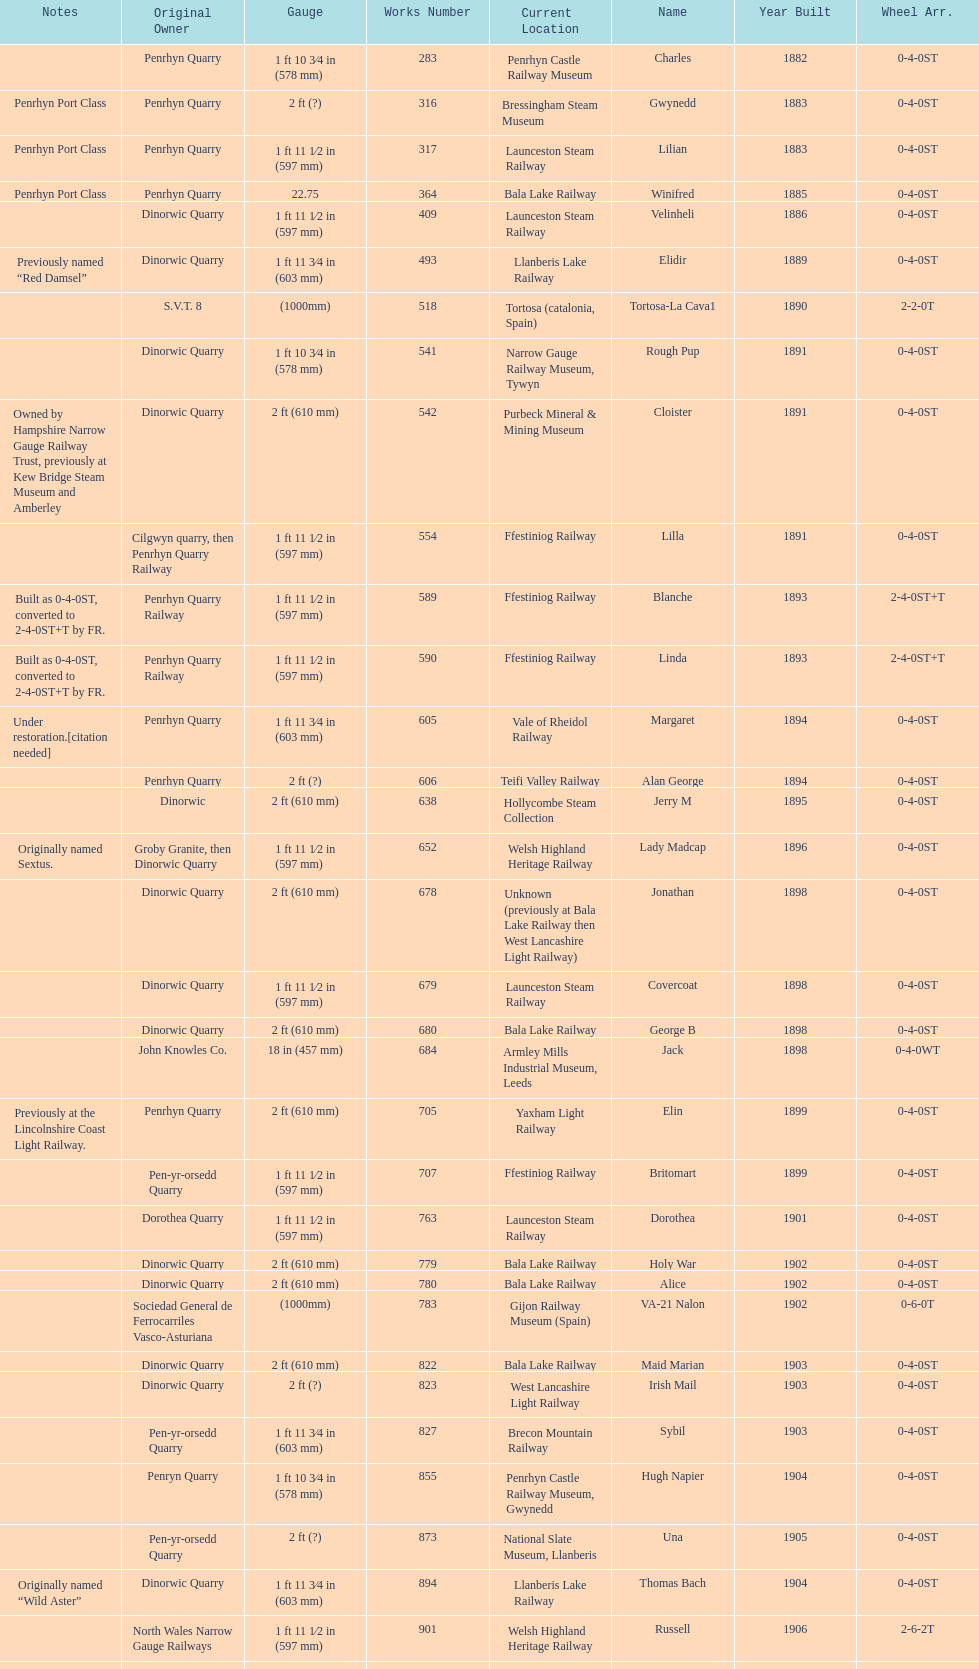After 1940, how many steam locomotives were built? 2. 